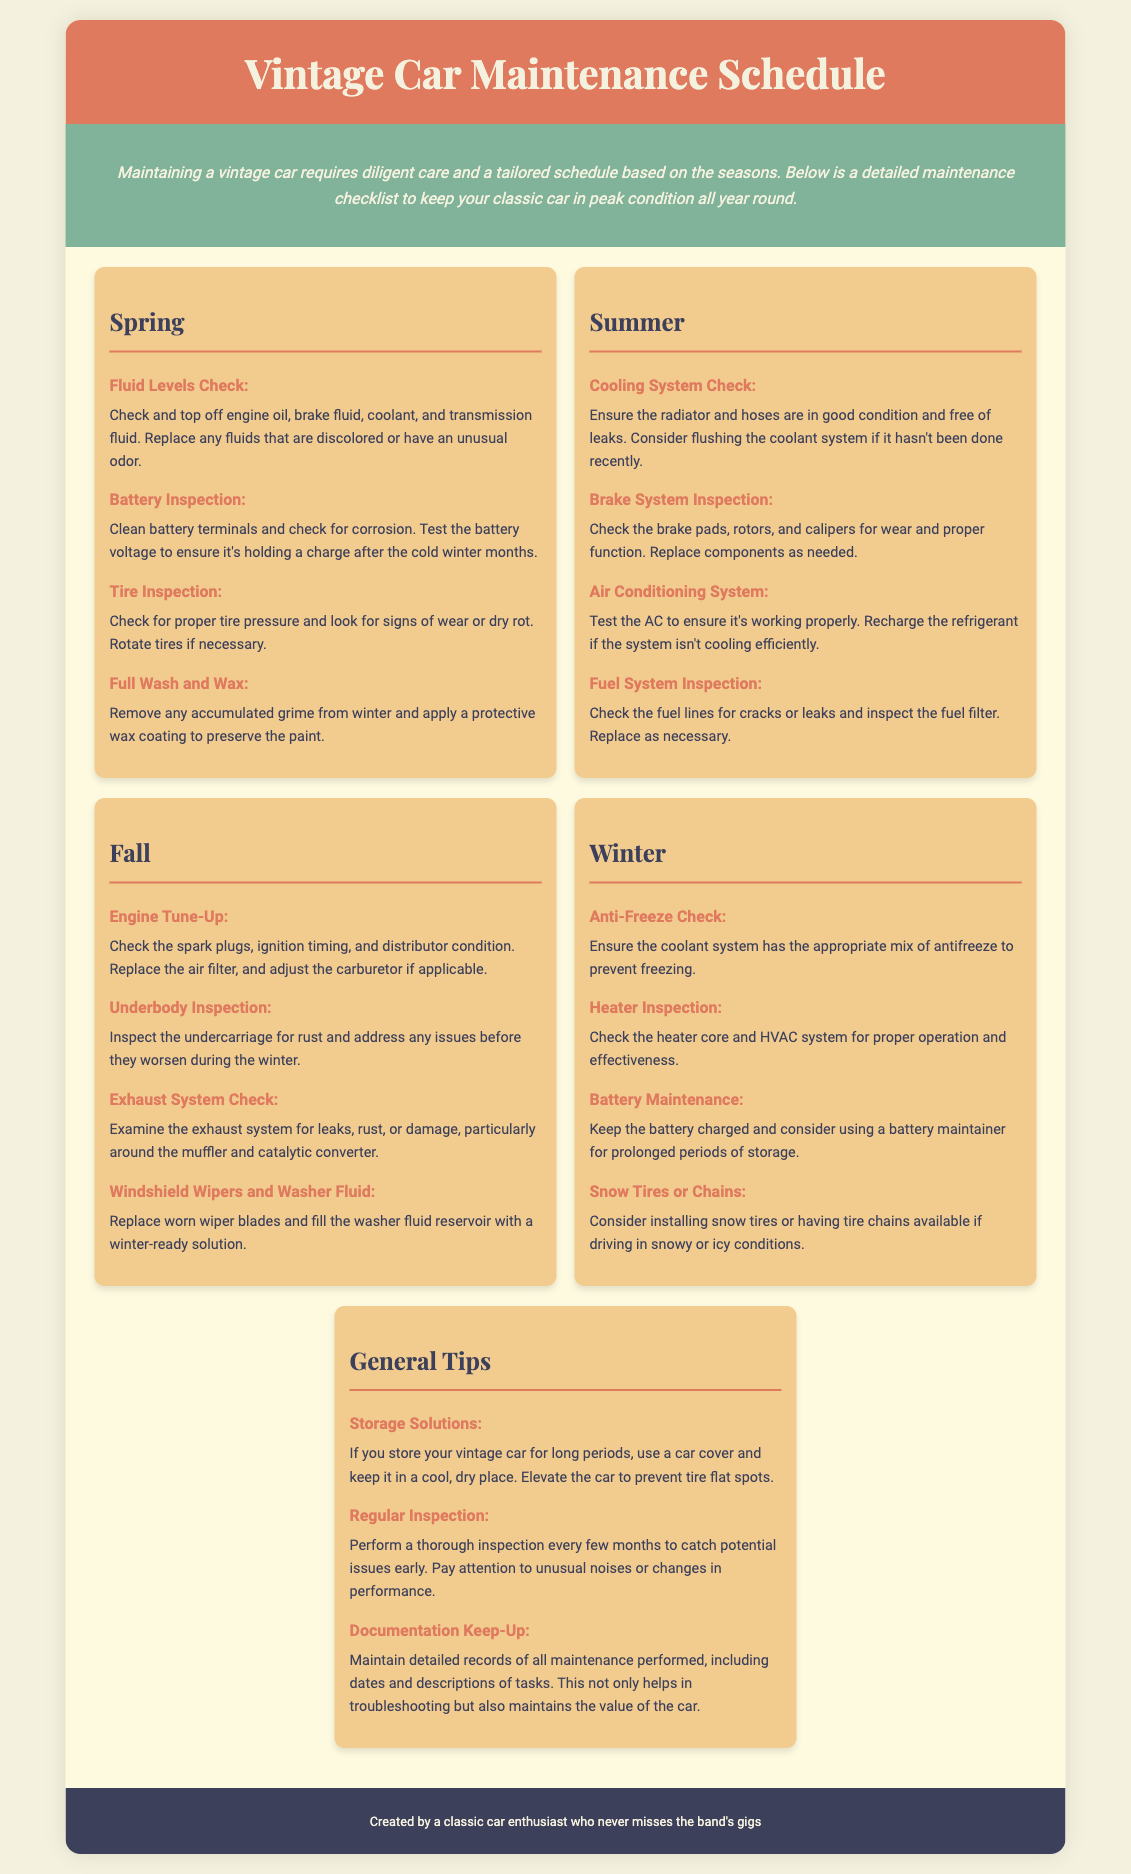What is the title of the document? The title is indicated at the top of the document, stating the main focus on vintage car maintenance.
Answer: Vintage Car Maintenance Schedule How many seasonal sections are included in the document? The document lists a maintenance schedule organized by different seasons, specifically mentioning Spring, Summer, Fall, and Winter.
Answer: Four What task should be performed in Spring for battery maintenance? The Spring section includes a task specifically focused on battery maintenance and inspection for corrosion.
Answer: Battery Inspection What is recommended for tire conditions in Spring? The Spring section advises checking the tire pressure and looking for wear or dry rot and rotating them if necessary.
Answer: Tire Inspection What should be inspected during the Fall for rust issues? In the Fall section, it mentions inspecting the undercarriage to find and address rust issues before winter.
Answer: Underbody Inspection What is a general tip for storing a vintage car? One of the general tips suggests methods for storing a vintage car effectively.
Answer: Storage Solutions What is checked in the Summer for air conditioning? The Summer maintenance tasks include ensuring the functionality of the AC system for optimal performance.
Answer: Air Conditioning System What type of car maintenance inspection is recommended every few months? A routine check is advised for assessing the vehicle's overall condition over time.
Answer: Regular Inspection What should be done to the windshield wipers in Fall? The Fall maintenance tasks include replacing worn wiper blades.
Answer: Replace worn wiper blades 